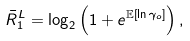Convert formula to latex. <formula><loc_0><loc_0><loc_500><loc_500>{ { \bar { R } } _ { 1 } ^ { L } } & = { { \log } _ { 2 } } \left ( 1 + e ^ { \mathbb { E } \left [ { \ln \gamma _ { o } } \right ] } \right ) ,</formula> 